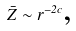Convert formula to latex. <formula><loc_0><loc_0><loc_500><loc_500>\bar { Z } \sim r ^ { - 2 c } \text {, }</formula> 